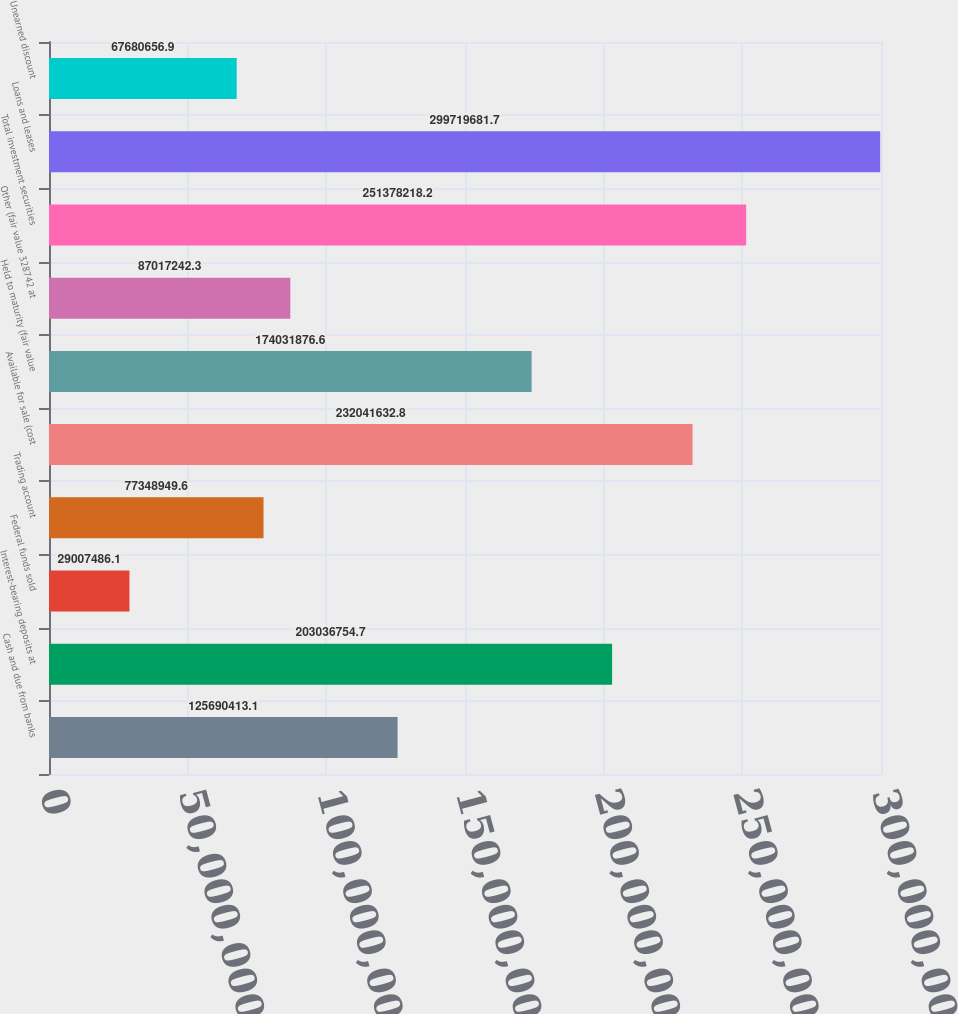Convert chart. <chart><loc_0><loc_0><loc_500><loc_500><bar_chart><fcel>Cash and due from banks<fcel>Interest-bearing deposits at<fcel>Federal funds sold<fcel>Trading account<fcel>Available for sale (cost<fcel>Held to maturity (fair value<fcel>Other (fair value 328742 at<fcel>Total investment securities<fcel>Loans and leases<fcel>Unearned discount<nl><fcel>1.2569e+08<fcel>2.03037e+08<fcel>2.90075e+07<fcel>7.73489e+07<fcel>2.32042e+08<fcel>1.74032e+08<fcel>8.70172e+07<fcel>2.51378e+08<fcel>2.9972e+08<fcel>6.76807e+07<nl></chart> 